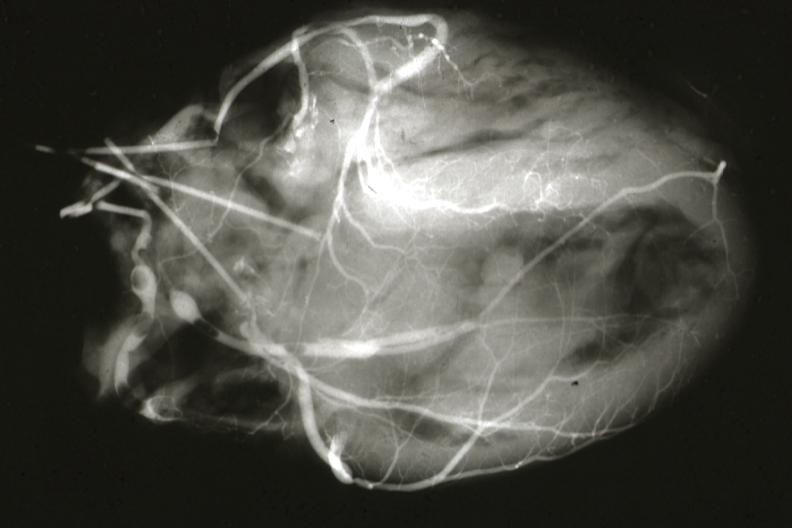where is this from?
Answer the question using a single word or phrase. Heart 